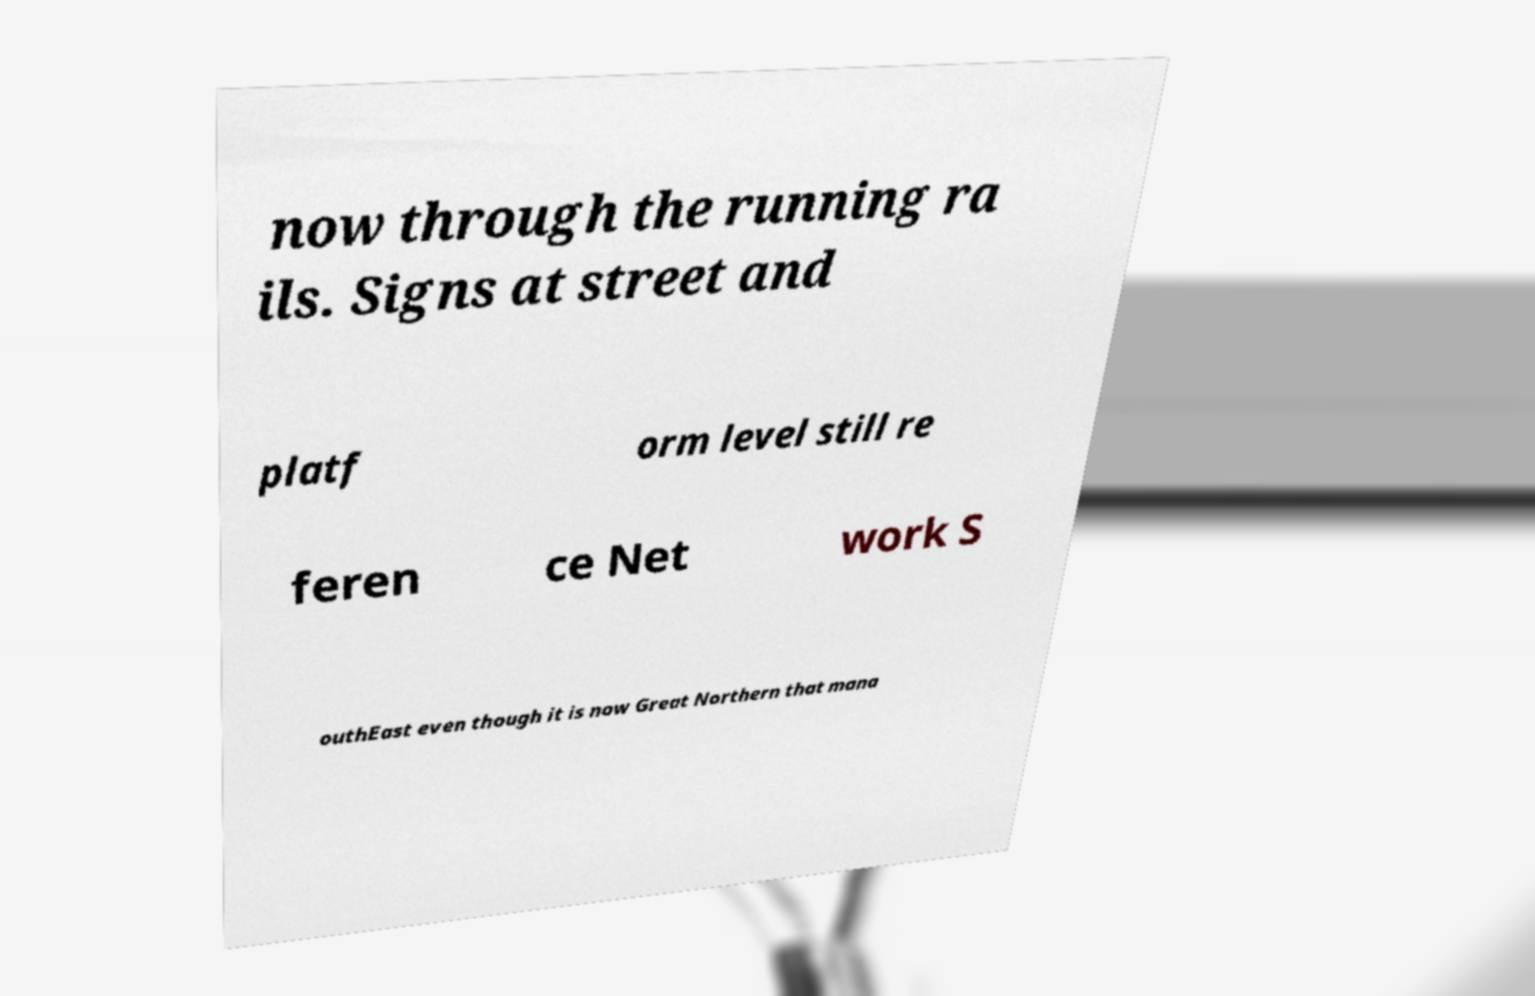Can you read and provide the text displayed in the image?This photo seems to have some interesting text. Can you extract and type it out for me? now through the running ra ils. Signs at street and platf orm level still re feren ce Net work S outhEast even though it is now Great Northern that mana 